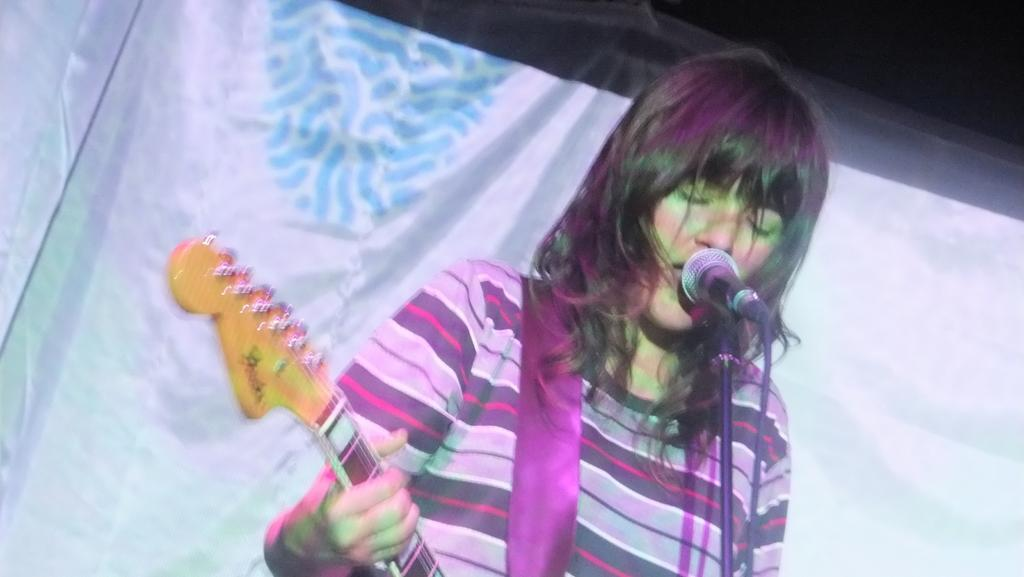Who is the main subject in the image? There is a girl in the image. What is the girl doing in the image? The girl is playing a guitar. What object is in front of the girl? There is a microphone in front of the girl. What color is the curtain in the background of the image? There is a blue curtain in the background of the image. Can you tell me how many snails are crawling on the guitar in the image? There are no snails present in the image, so it cannot be answered definitively. 